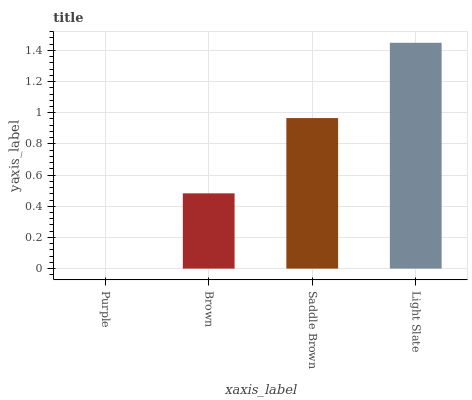Is Brown the minimum?
Answer yes or no. No. Is Brown the maximum?
Answer yes or no. No. Is Brown greater than Purple?
Answer yes or no. Yes. Is Purple less than Brown?
Answer yes or no. Yes. Is Purple greater than Brown?
Answer yes or no. No. Is Brown less than Purple?
Answer yes or no. No. Is Saddle Brown the high median?
Answer yes or no. Yes. Is Brown the low median?
Answer yes or no. Yes. Is Light Slate the high median?
Answer yes or no. No. Is Purple the low median?
Answer yes or no. No. 